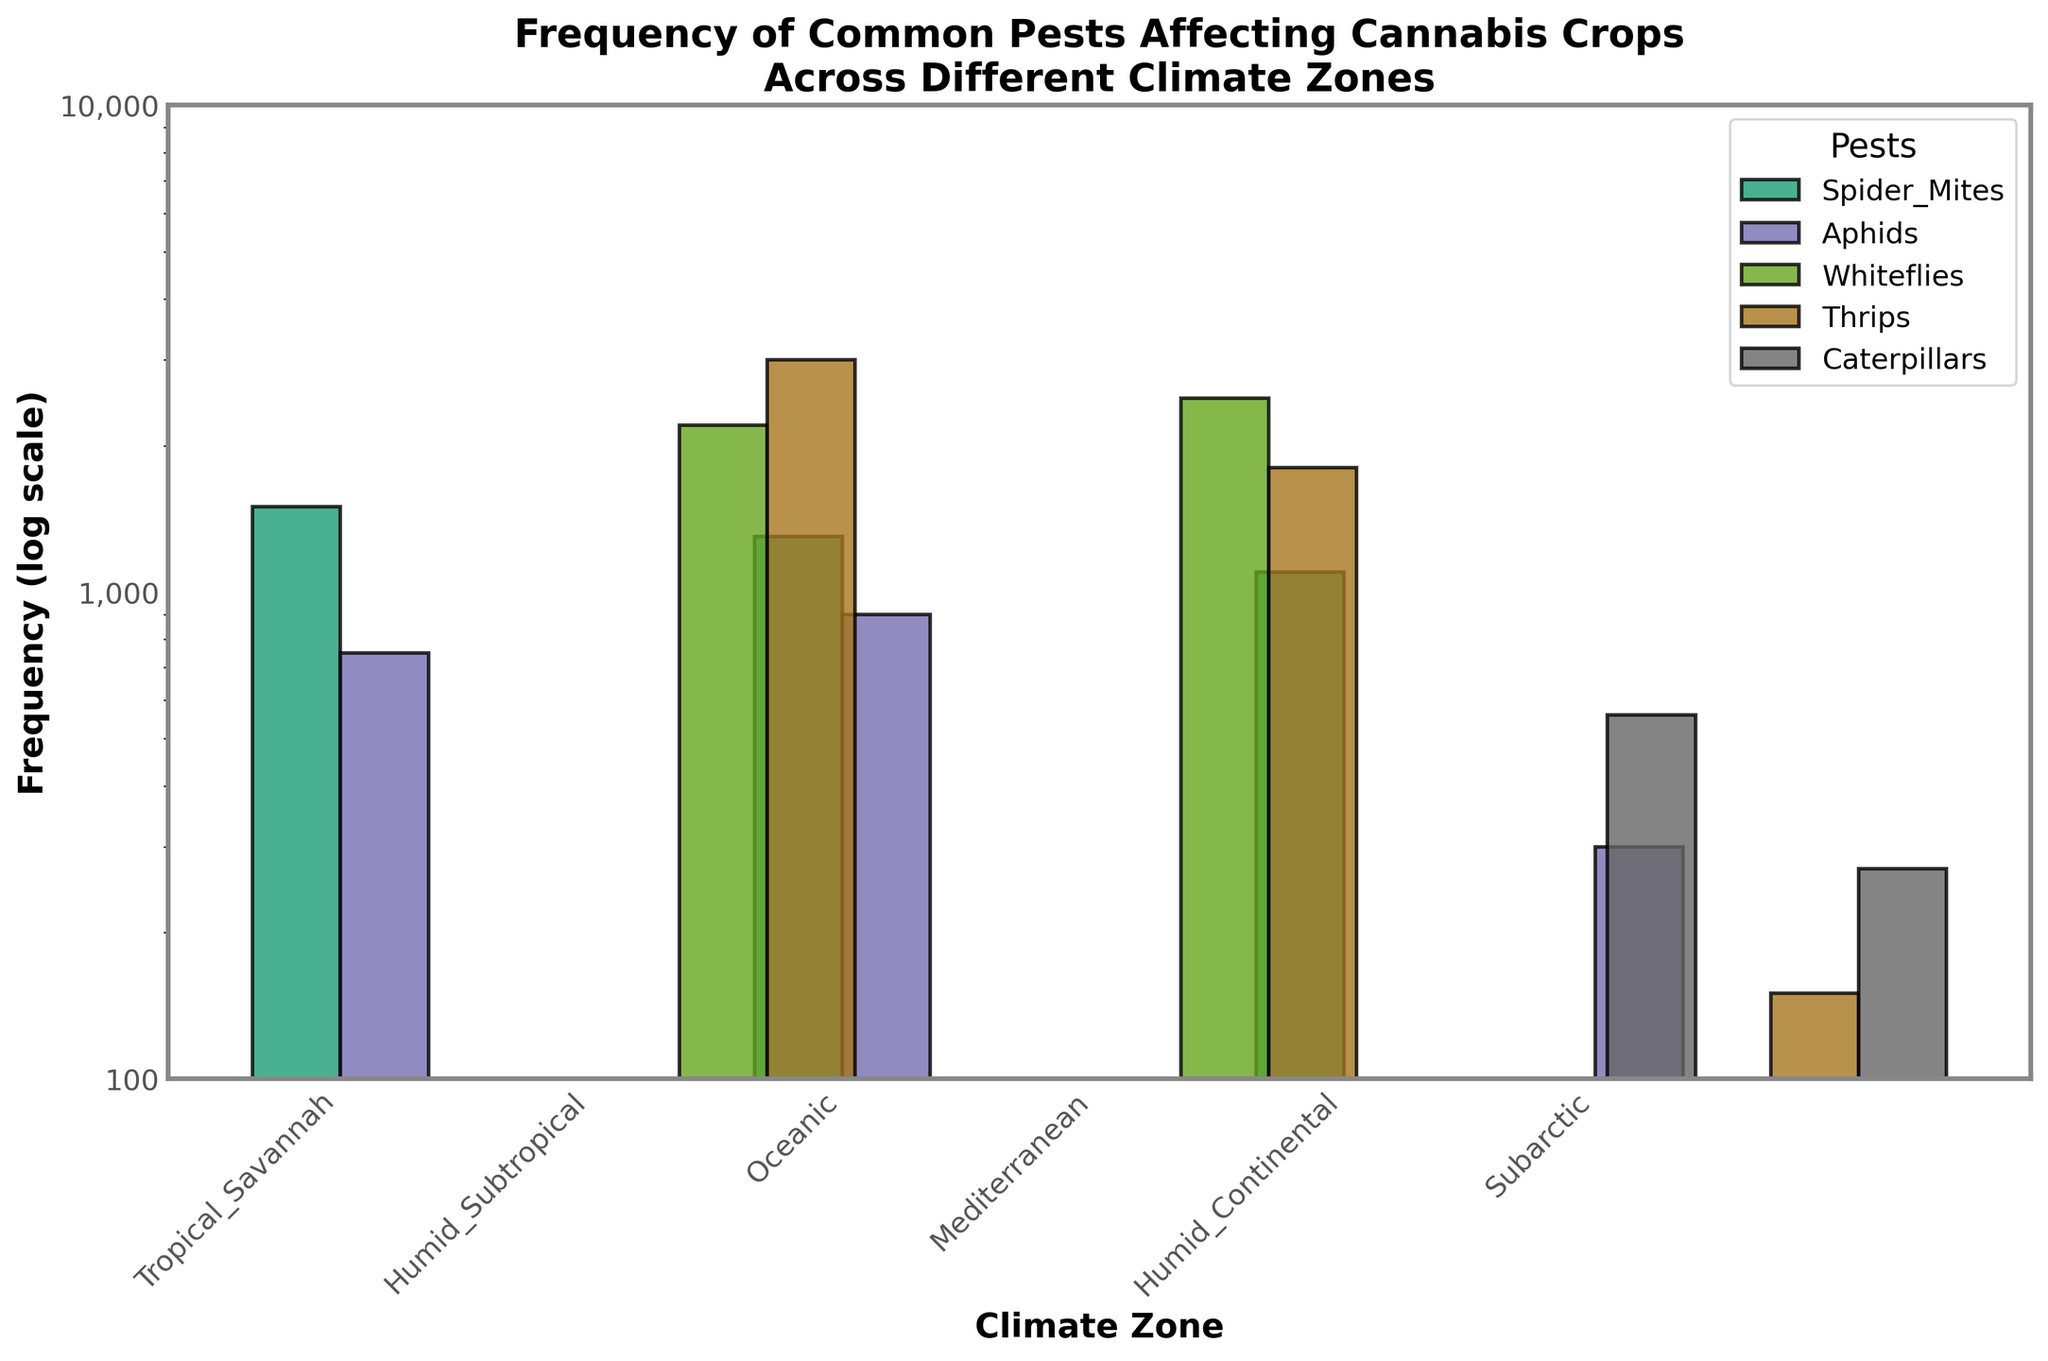What's the title of the plot? The title is generally located at the top of the plot. According to the image rendering description, it is "Frequency of Common Pests Affecting Cannabis Crops Across Different Climate Zones."
Answer: Frequency of Common Pests Affecting Cannabis Crops Across Different Climate Zones Which pest has the highest frequency in the Humid Subtropical climate zone? Locate the bar corresponding to the Humid Subtropical climate zone and compare the heights of the different bars representing pests. The tallest bar represents Thrips.
Answer: Thrips What is the frequency of Whiteflies in the Mediterranean climate zone? Find the Mediterranean climate zone on the x-axis and identify the corresponding bar for Whiteflies by its color. The value at the top of this bar is 2500.
Answer: 2500 Which climate zone has the lowest frequency of Aphids? Look at the bars representing Aphids across all climate zones and find the shortest one. The Subarctic climate zone has the shortest bar for Aphids.
Answer: Subarctic Compare the frequencies of Spider Mites in Tropical Savannah and Oceanic climate zones. Which one is higher? Identify the bars for Spider Mites in both Tropical Savannah and Oceanic climate zones. Compare their heights. The bar for Tropical Savannah is higher.
Answer: Tropical Savannah What is the combined frequency of Caterpillars in the Humid Continental and Subarctic climate zones? Locate the bars for Caterpillars in both Humid Continental and Subarctic climate zones. Add their frequencies (560 + 270).
Answer: 830 Which pest has the most variation in frequency across the climate zones? Observe the range of bar heights for each pest. Thrips show significant variation, ranging from as low as 150 in Subarctic to as high as 3000 in Humid Subtropical.
Answer: Thrips What is the difference in the frequency of Spider Mites between Humid Continental and Oceanic climate zones? Find the frequencies of Spider Mites in both Humid Continental and Oceanic climate zones. Calculate the difference (1300 - 1100).
Answer: 200 Are there any climate zones where Thrips are not present? Check each climate zone for bars representing Thrips. All climate zones are accounted for Thrips; no bar is completely absent for this pest.
Answer: No 